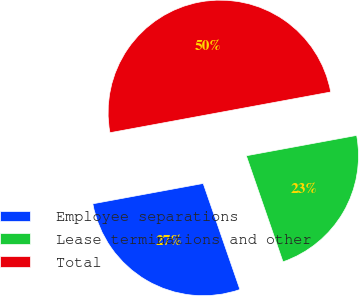Convert chart to OTSL. <chart><loc_0><loc_0><loc_500><loc_500><pie_chart><fcel>Employee separations<fcel>Lease terminations and other<fcel>Total<nl><fcel>27.4%<fcel>22.6%<fcel>50.0%<nl></chart> 